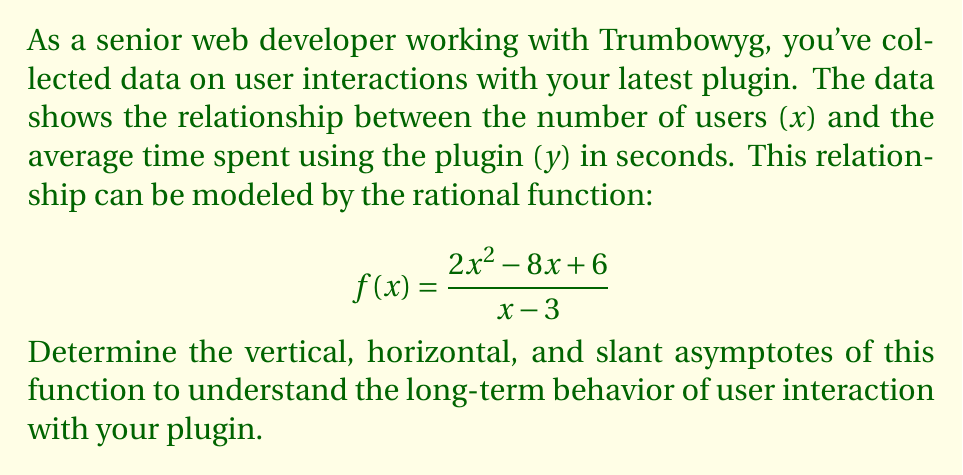Help me with this question. To find the asymptotes of the rational function $f(x) = \frac{2x^2 - 8x + 6}{x - 3}$, we'll follow these steps:

1. Vertical asymptote:
   The vertical asymptote occurs where the denominator equals zero.
   $x - 3 = 0$
   $x = 3$

2. Horizontal asymptote:
   Compare the degrees of the numerator and denominator.
   Degree of numerator = 2
   Degree of denominator = 1
   Since the degree of the numerator is greater than the degree of the denominator, there is no horizontal asymptote. Instead, we'll have a slant asymptote.

3. Slant asymptote:
   To find the slant asymptote, we perform long division of the numerator by the denominator:

   $$\frac{2x^2 - 8x + 6}{x - 3} = 2x + 2 + \frac{12}{x-3}$$

   The slant asymptote is the polynomial part of this result: $y = 2x + 2$

Therefore, we have:
- Vertical asymptote: $x = 3$
- No horizontal asymptote
- Slant asymptote: $y = 2x + 2$
Answer: Vertical: $x = 3$; Slant: $y = 2x + 2$ 